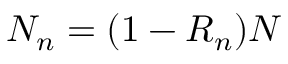Convert formula to latex. <formula><loc_0><loc_0><loc_500><loc_500>N _ { n } = ( 1 - R _ { n } ) N</formula> 